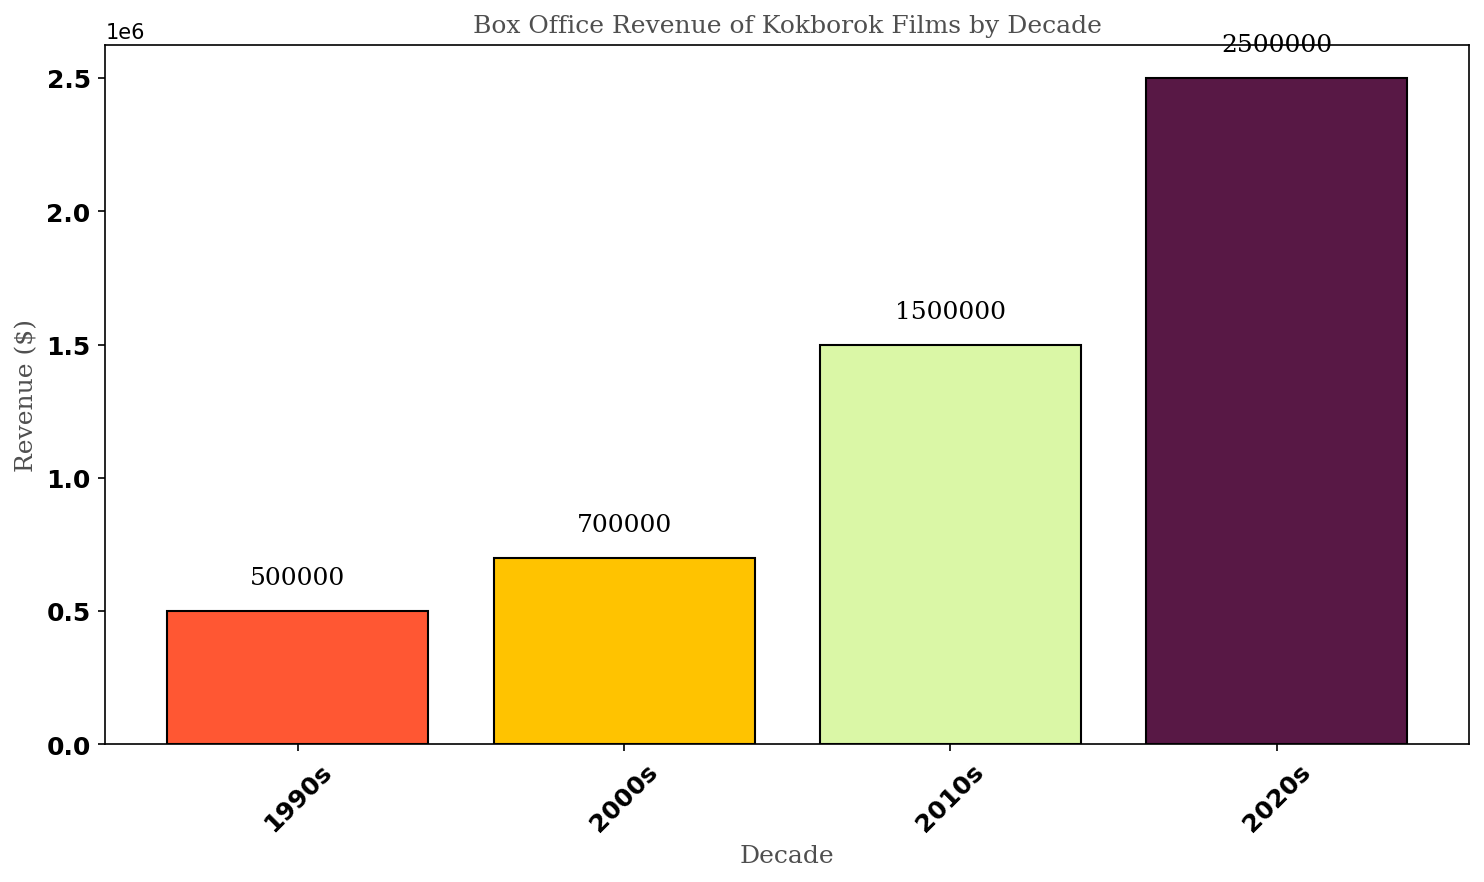What's the total box office revenue of Kokborok films from the 1990s to 2020s? Sum the revenues from each decade: 500,000 (1990s) + 700,000 (2000s) + 1,500,000 (2010s) + 2,500,000 (2020s) = 5,200,000
Answer: 5,200,000 Which decade had the highest box office revenue for Kokborok films? Compare the revenues across all decades: 500,000 (1990s), 700,000 (2000s), 1,500,000 (2010s), and 2,500,000 (2020s). The highest is 2,500,000 in the 2020s.
Answer: 2020s What is the difference in box office revenue between the 2010s and the 2000s? Subtract the revenue of the 2000s from the 2010s: 1,500,000 - 700,000 = 800,000
Answer: 800,000 What is the average box office revenue per decade? Total revenue is 5,200,000 over 4 decades. Average is 5,200,000 / 4 = 1,300,000
Answer: 1,300,000 Which decade saw the smallest increase in box office revenue compared to the previous one? Calculate revenue increases: 2000s 200,000 increase from 1990s (700,000 - 500,000), 2010s 800,000 increase from 2000s (1,500,000 - 700,000), 2020s 1,000,000 increase from 2010s (2,500,000 - 1,500,000). The smallest increase is from 1990s to 2000s, 200,000.
Answer: 2000s Which decade is represented by the shortest bar? The 1990s have the revenue of 500,000, the shortest compared to other decades.
Answer: 1990s How much more revenue did the 2020s generation films make compared to the combined total of the 1990s and 2000s? Combined revenue of 1990s and 2000s is 500,000 + 700,000 = 1,200,000. Difference with 2020s is 2,500,000 - 1,200,000 = 1,300,000
Answer: 1,300,000 Which decade's bar is represented by the color green? Green is used for the 2010s bar in the chart.
Answer: 2010s What is the median box office revenue among the decades listed? Ordering revenues: 500,000 (1990s), 700,000 (2000s), 1,500,000 (2010s), 2,500,000 (2020s). Median is the average of 700,000 and 1,500,000: (700,000 + 1,500,000) / 2 = 1,100,000
Answer: 1,100,000 